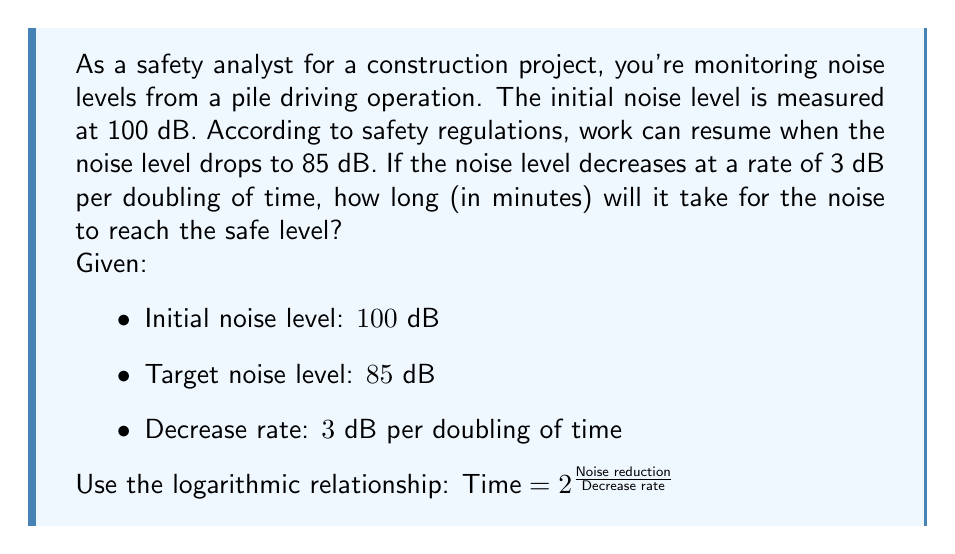Give your solution to this math problem. To solve this problem, we'll follow these steps:

1) Calculate the total noise reduction needed:
   $\text{Noise reduction} = 100 \text{ dB} - 85 \text{ dB} = 15 \text{ dB}$

2) Use the given logarithmic relationship:
   $\text{Time} = 2^{\frac{\text{Noise reduction}}{\text{Decrease rate}}}$

3) Substitute the values:
   $\text{Time} = 2^{\frac{15 \text{ dB}}{3 \text{ dB}}} = 2^5 = 32$

4) This means it will take 32 time units for the noise to decrease to the safe level.

5) To determine what these time units represent, we need to consider the initial time unit. Let's assume the initial measurement was taken after 1 minute.

6) The time doubles with each 3 dB decrease, so the time progression would be:
   1 minute, 2 minutes, 4 minutes, 8 minutes, 16 minutes, 32 minutes

Therefore, it will take 32 minutes for the noise level to decrease from 100 dB to 85 dB.
Answer: It will take 32 minutes for the noise level to decrease to the safe level of 85 dB. 